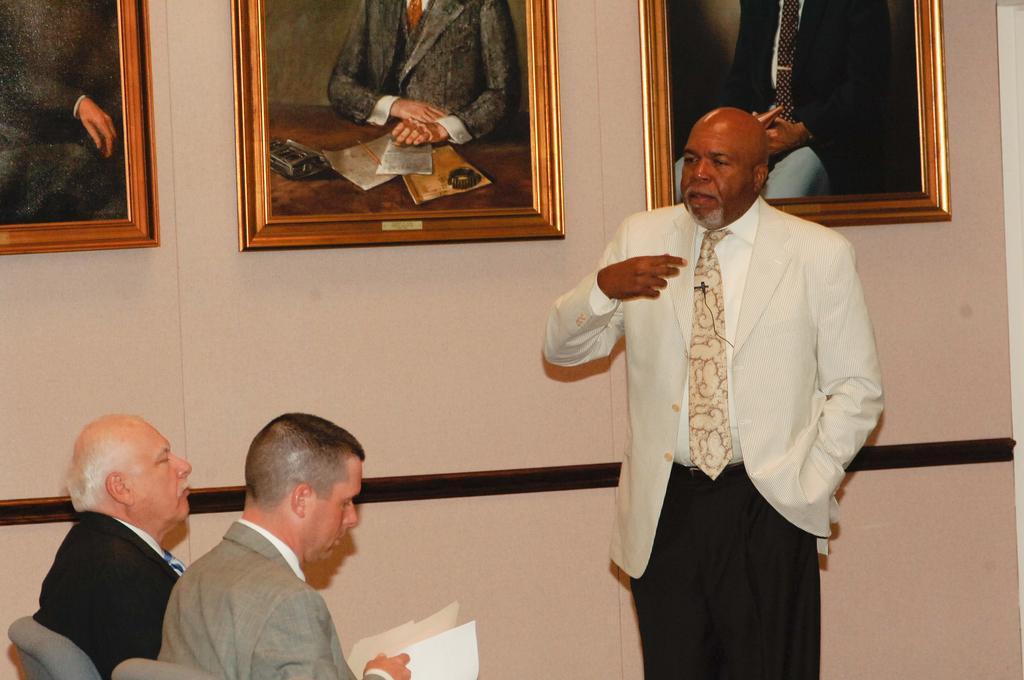Can you describe this image briefly? In this image, we can see some people. Among them, some people are sitting. We can also see the wall with some photo frames. 